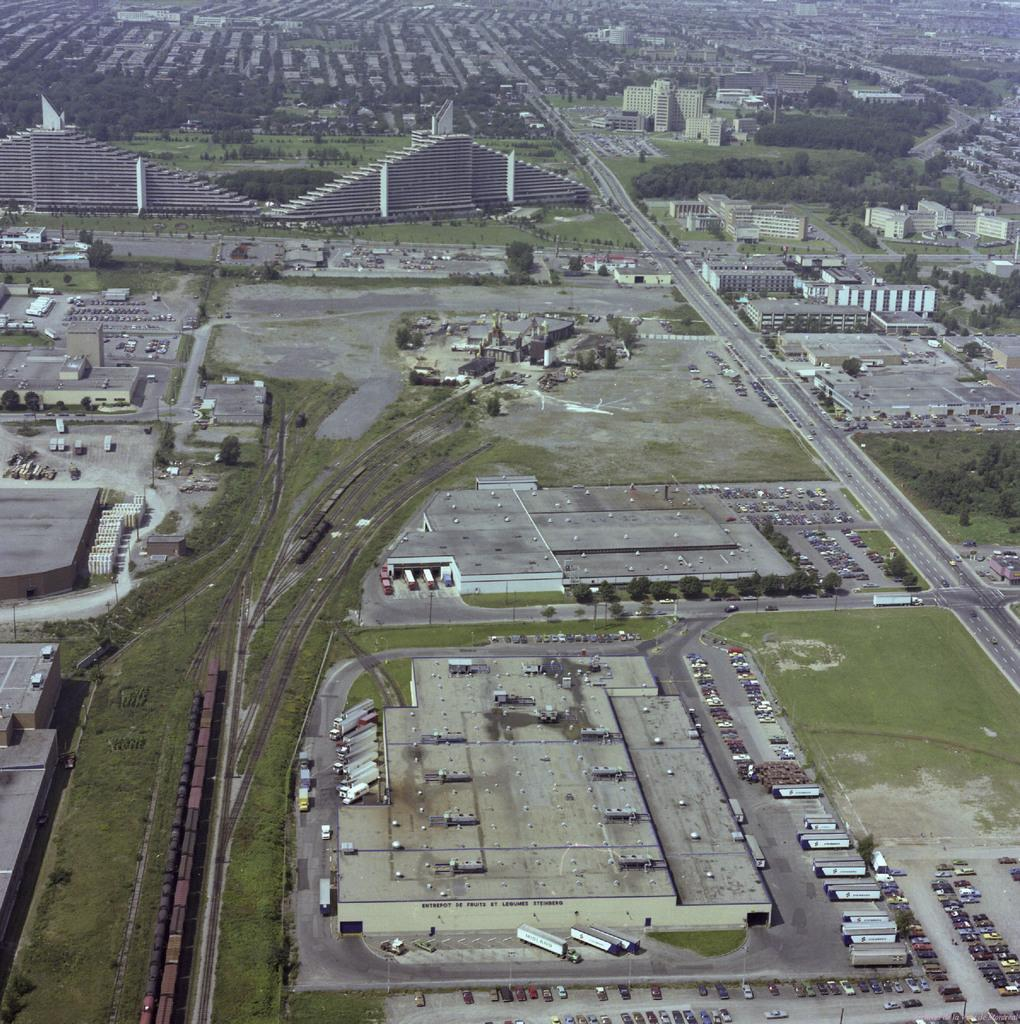What types of vehicles can be seen on the ground in the image? There are vehicles on the ground in the image, but the specific types are not mentioned. What type of natural environment is visible in the image? There is grass visible in the image, which suggests a natural environment. What type of infrastructure is present in the image? There are roads, trees, and buildings in the image, indicating the presence of infrastructure. What are the unspecified objects in the image? The facts do not specify the nature of the unspecified objects in the image. What news headline is displayed on the sign in the image? There is no sign present in the image, so there is no news headline to be displayed. What type of pets can be seen in the image? There are no pets visible in the image. 